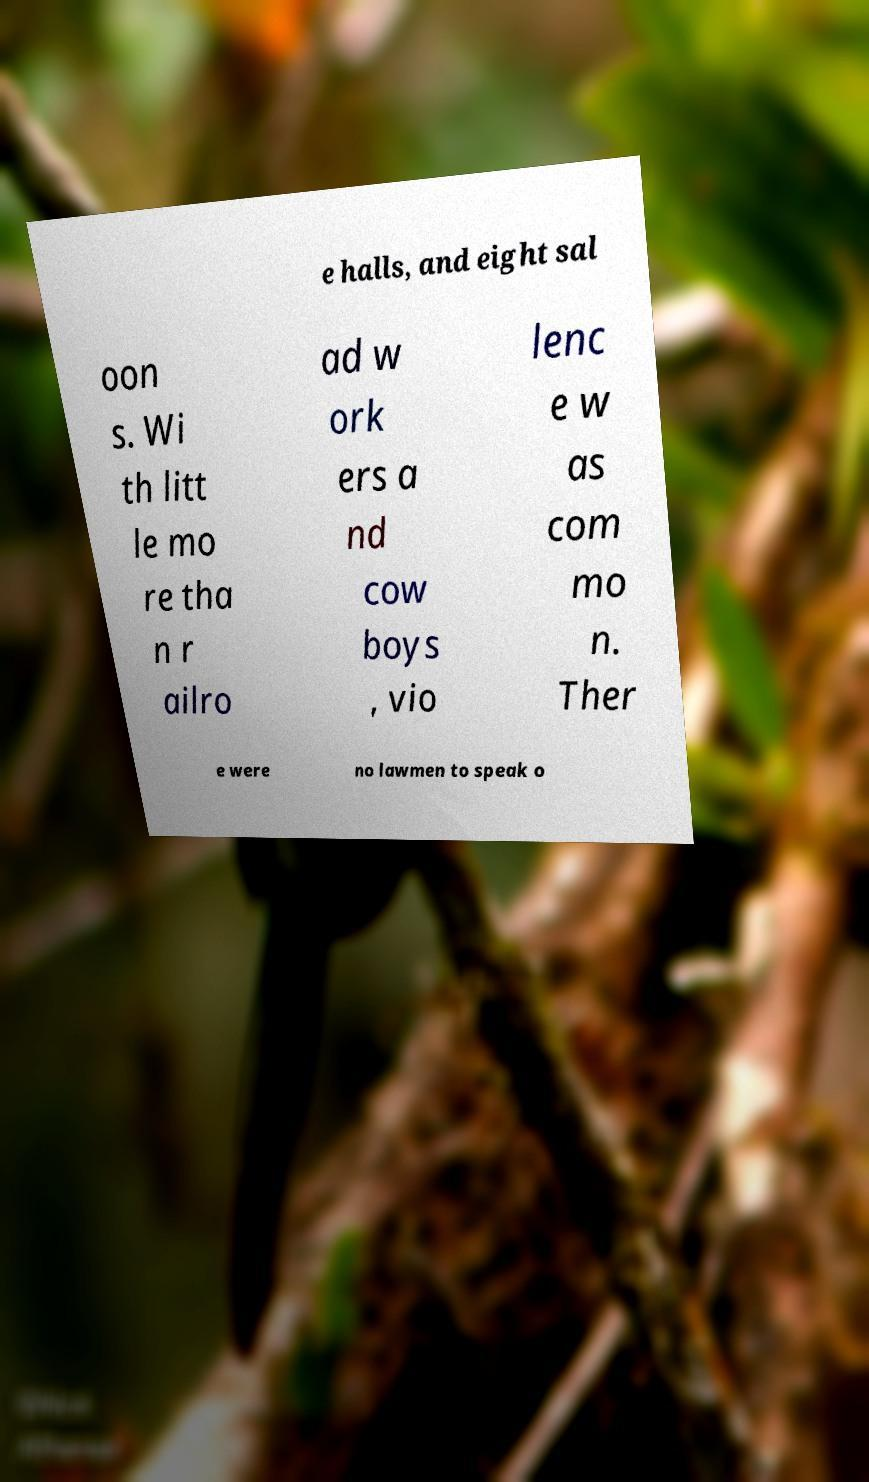Could you extract and type out the text from this image? e halls, and eight sal oon s. Wi th litt le mo re tha n r ailro ad w ork ers a nd cow boys , vio lenc e w as com mo n. Ther e were no lawmen to speak o 